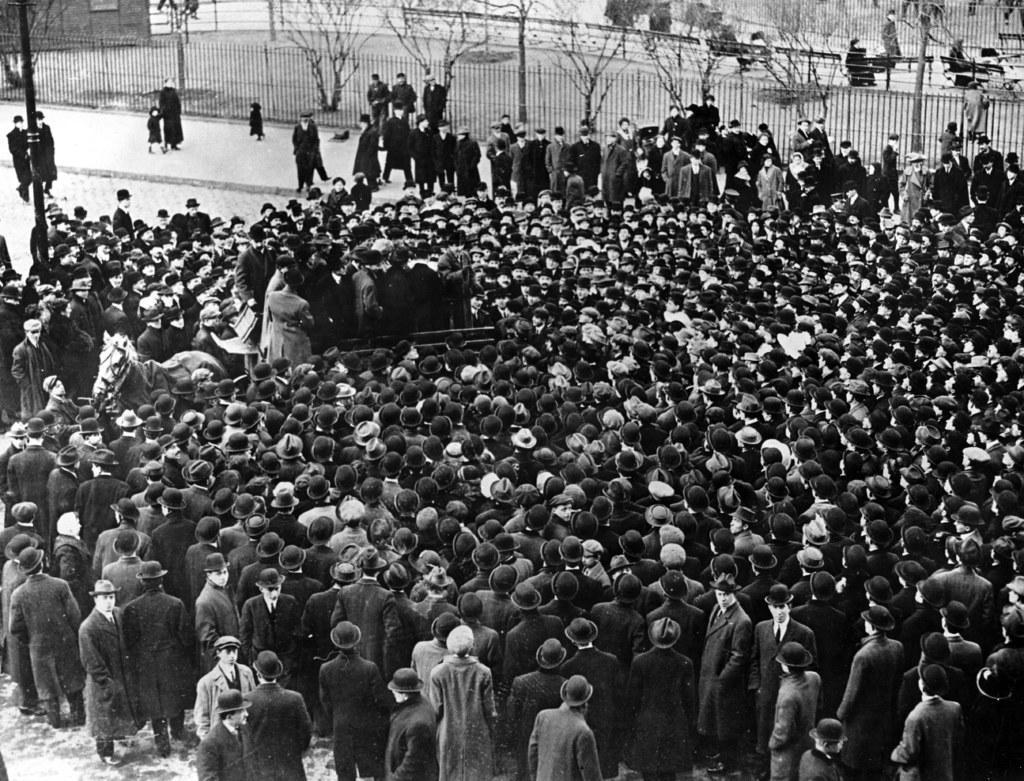Describe this image in one or two sentences. This is a black and white image. In this image we can see a crowd standing on the road, grills, trees and persons sitting on the chairs. 